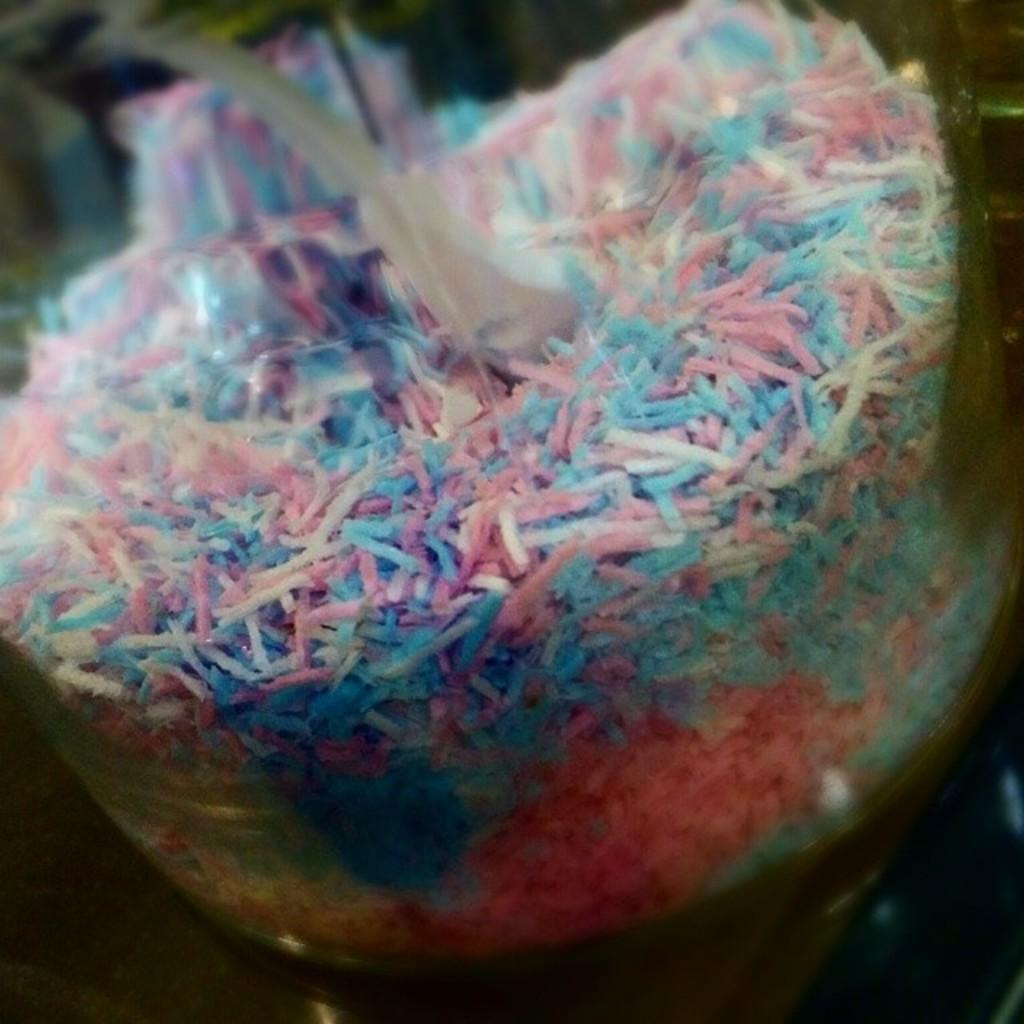What type of sweet is visible in the image? There is candy in the image. How is the candy stored in the image? The candy is in a glass jar. What type of badge can be seen on the candy in the image? There is no badge present on the candy in the image. What shape is the candy in the image? The provided facts do not mention the shape of the candy, so it cannot be determined from the image. 